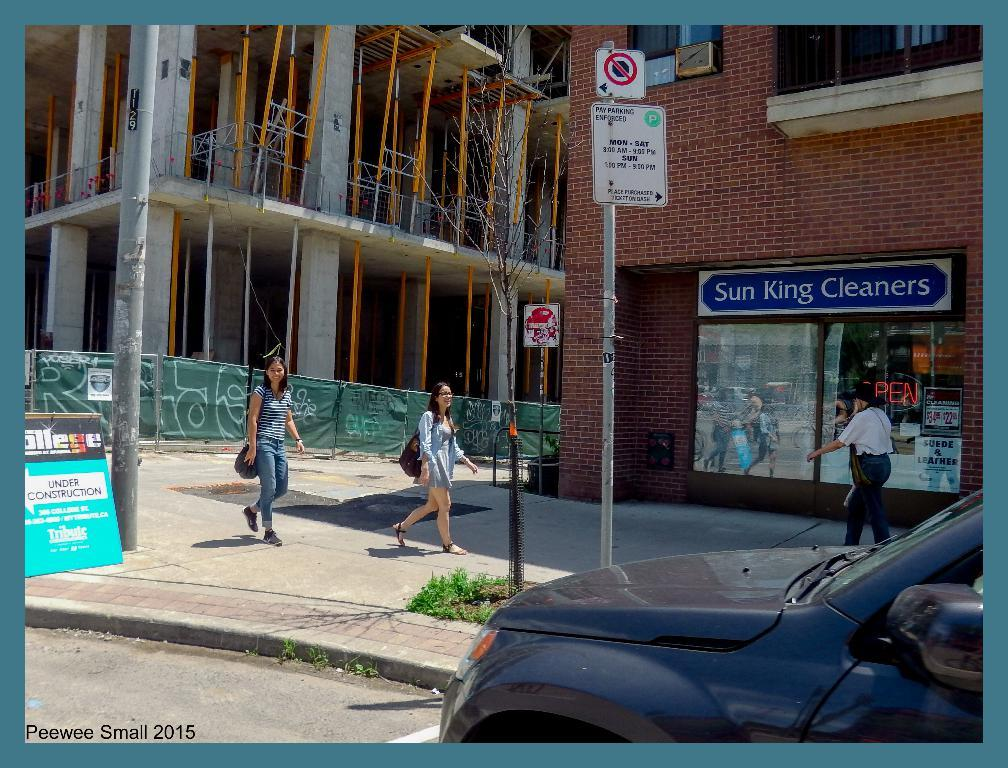What is located in the center of the image? There are buildings in the center of the image. What are the people in the image doing? People are walking in the image. Can you describe any objects or structures in the image? There is a sign board and a pole in the image. What can be seen on the right side of the image? There is a car on the right side of the image. What type of garden can be seen in the image? There is no garden present in the image. How does the car brake while driving in the image? The car does not appear to be in motion in the image, so the question of braking is not applicable. 